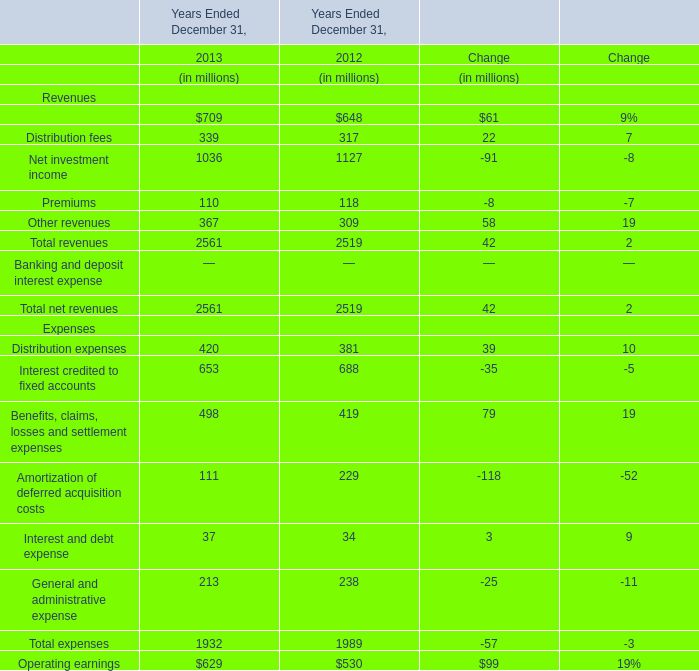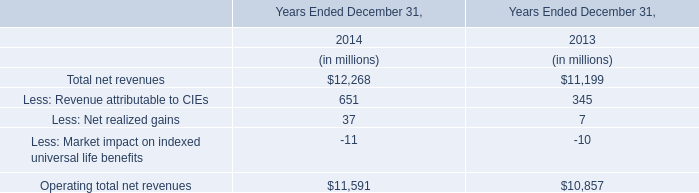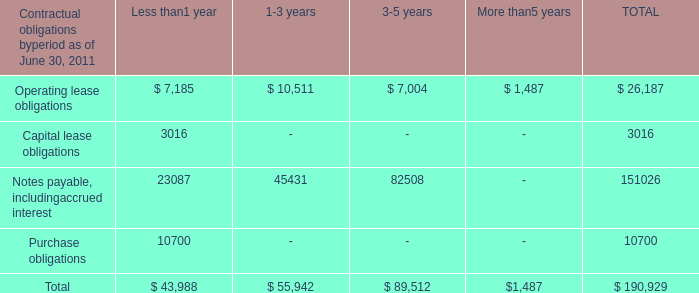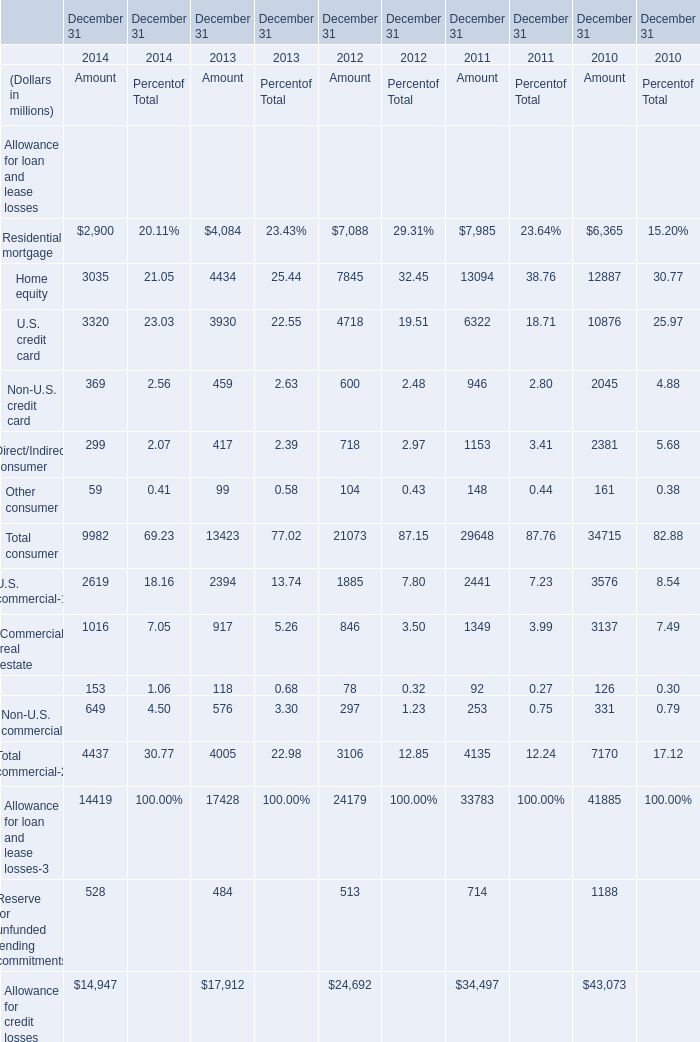In the year with lowest amount of Premiums in table 0, what's the increasing rate of Distribution fees in table 0? 
Answer: 7%. 